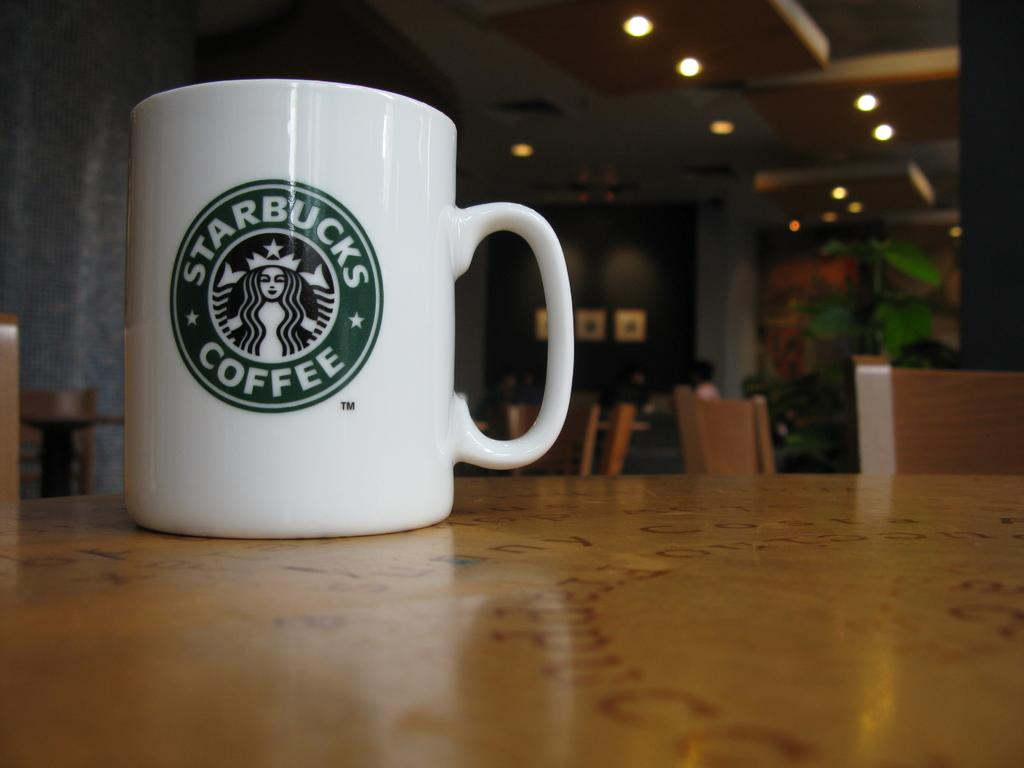<image>
Summarize the visual content of the image. A Starbucks coffee mug is sitting alone on a table in a shop. 